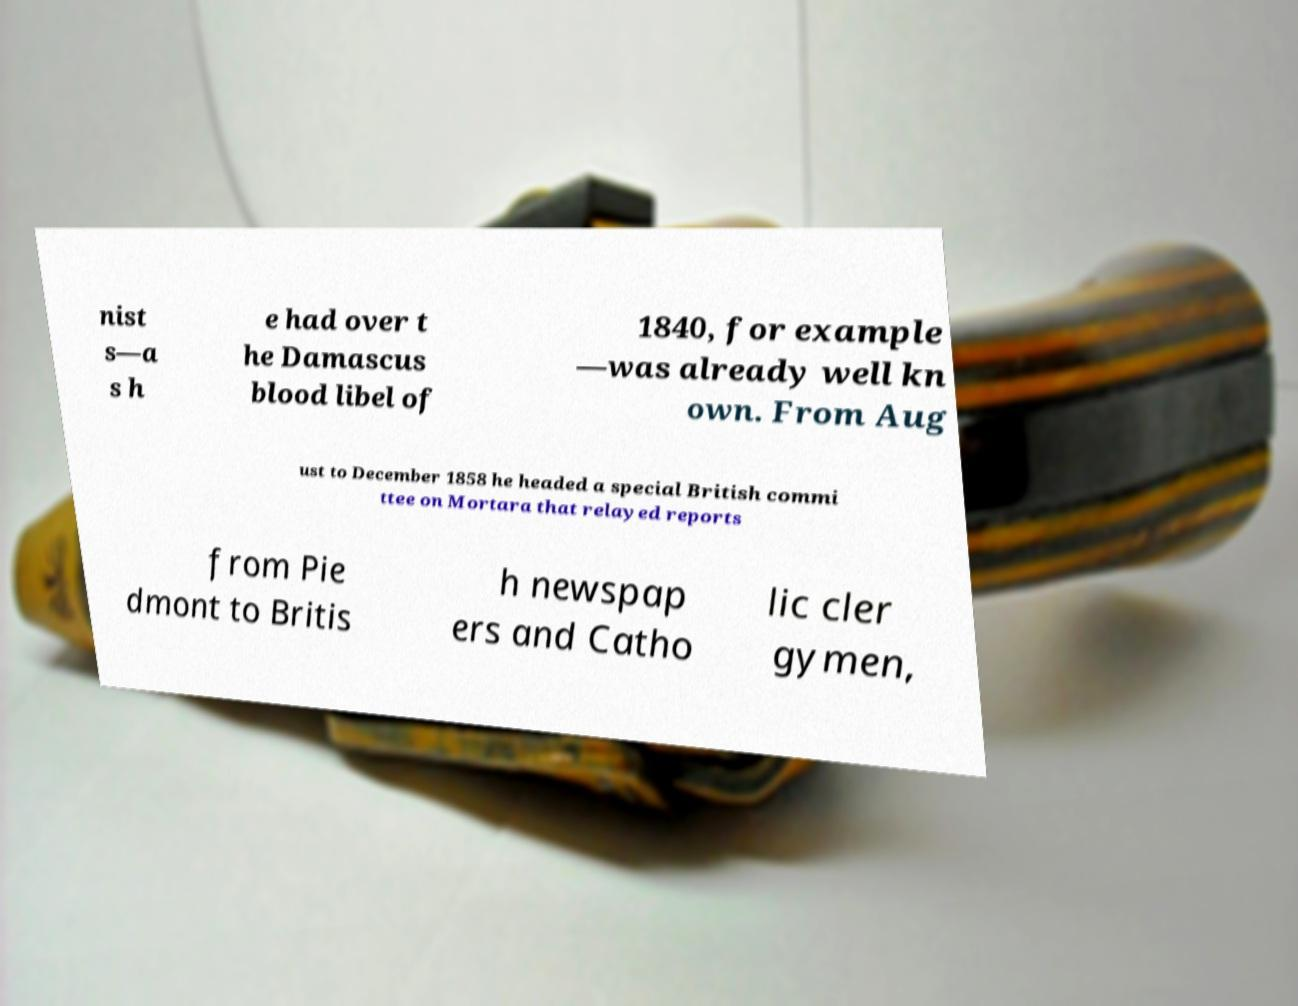For documentation purposes, I need the text within this image transcribed. Could you provide that? nist s—a s h e had over t he Damascus blood libel of 1840, for example —was already well kn own. From Aug ust to December 1858 he headed a special British commi ttee on Mortara that relayed reports from Pie dmont to Britis h newspap ers and Catho lic cler gymen, 